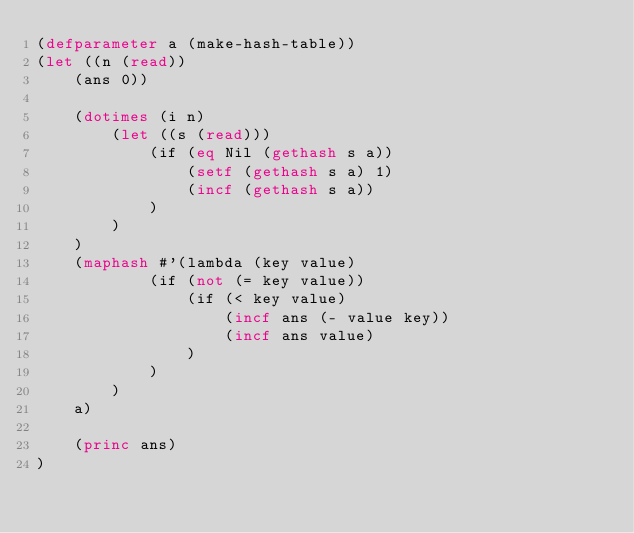Convert code to text. <code><loc_0><loc_0><loc_500><loc_500><_Lisp_>(defparameter a (make-hash-table))
(let ((n (read))
    (ans 0))
    
    (dotimes (i n)
        (let ((s (read)))
            (if (eq Nil (gethash s a))
                (setf (gethash s a) 1)
                (incf (gethash s a))
            )
        )
    )
    (maphash #'(lambda (key value)
            (if (not (= key value))
                (if (< key value)
                    (incf ans (- value key))
                    (incf ans value)
                )
            )
        )
    a)

    (princ ans)
)</code> 